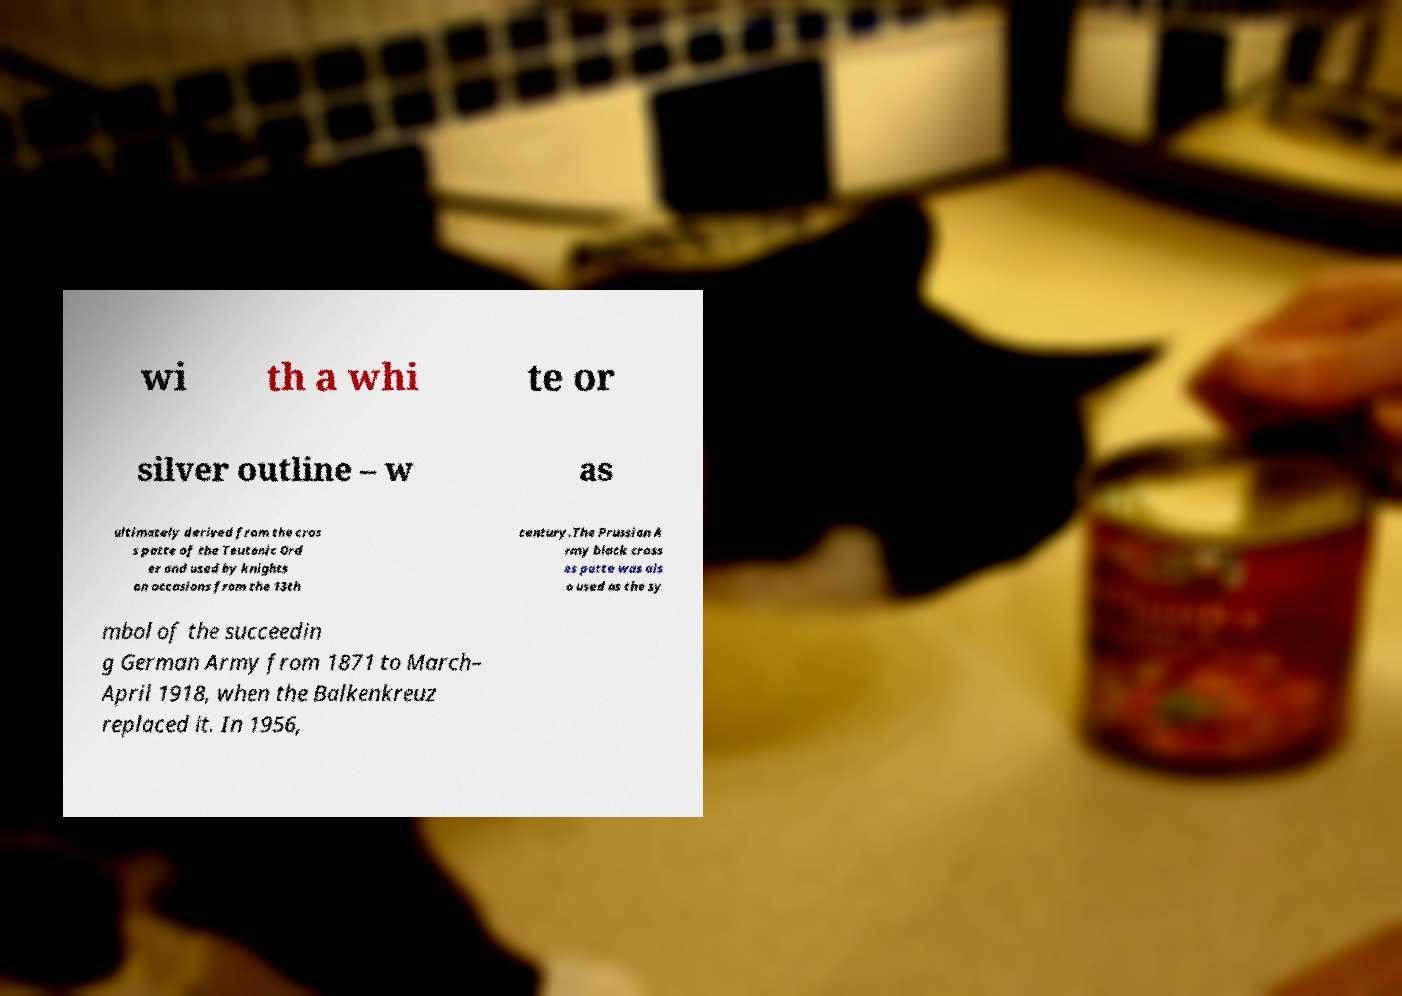Can you accurately transcribe the text from the provided image for me? wi th a whi te or silver outline – w as ultimately derived from the cros s patte of the Teutonic Ord er and used by knights on occasions from the 13th century.The Prussian A rmy black cross es patte was als o used as the sy mbol of the succeedin g German Army from 1871 to March– April 1918, when the Balkenkreuz replaced it. In 1956, 